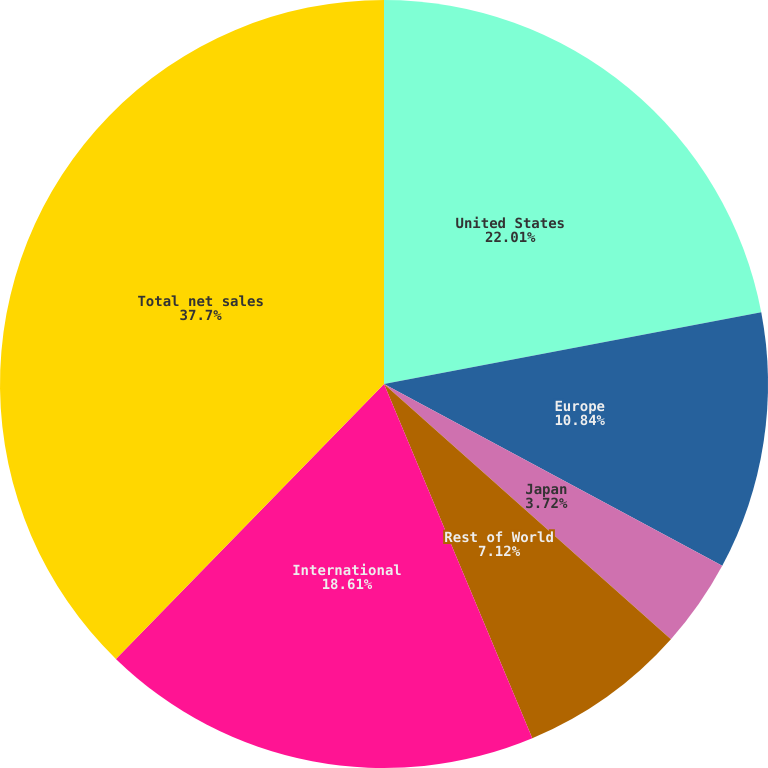Convert chart. <chart><loc_0><loc_0><loc_500><loc_500><pie_chart><fcel>United States<fcel>Europe<fcel>Japan<fcel>Rest of World<fcel>International<fcel>Total net sales<nl><fcel>22.01%<fcel>10.84%<fcel>3.72%<fcel>7.12%<fcel>18.61%<fcel>37.7%<nl></chart> 